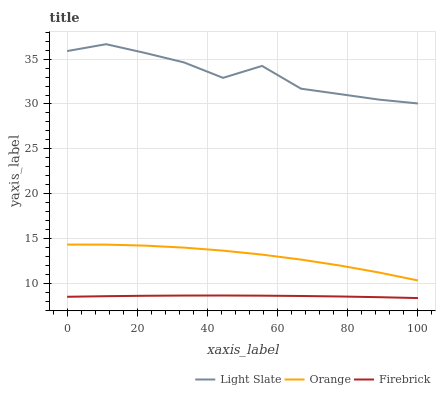Does Firebrick have the minimum area under the curve?
Answer yes or no. Yes. Does Light Slate have the maximum area under the curve?
Answer yes or no. Yes. Does Orange have the minimum area under the curve?
Answer yes or no. No. Does Orange have the maximum area under the curve?
Answer yes or no. No. Is Firebrick the smoothest?
Answer yes or no. Yes. Is Light Slate the roughest?
Answer yes or no. Yes. Is Orange the smoothest?
Answer yes or no. No. Is Orange the roughest?
Answer yes or no. No. Does Firebrick have the lowest value?
Answer yes or no. Yes. Does Orange have the lowest value?
Answer yes or no. No. Does Light Slate have the highest value?
Answer yes or no. Yes. Does Orange have the highest value?
Answer yes or no. No. Is Firebrick less than Orange?
Answer yes or no. Yes. Is Light Slate greater than Orange?
Answer yes or no. Yes. Does Firebrick intersect Orange?
Answer yes or no. No. 